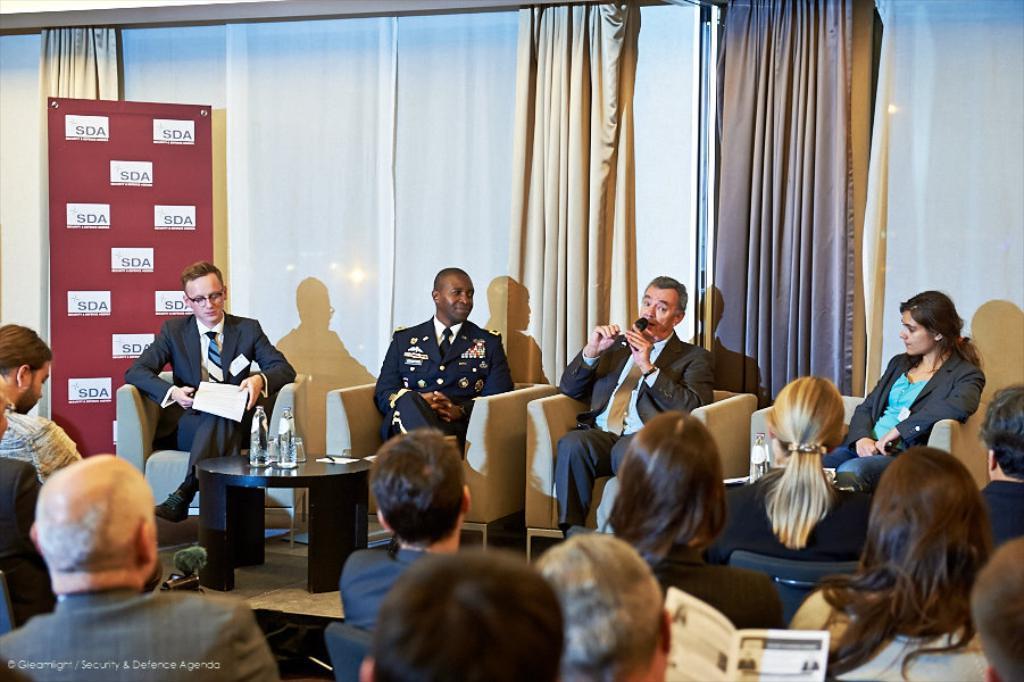Could you give a brief overview of what you see in this image? In the middle 4 persons are sitting on the sofa behind them there is a wall and curtains. 